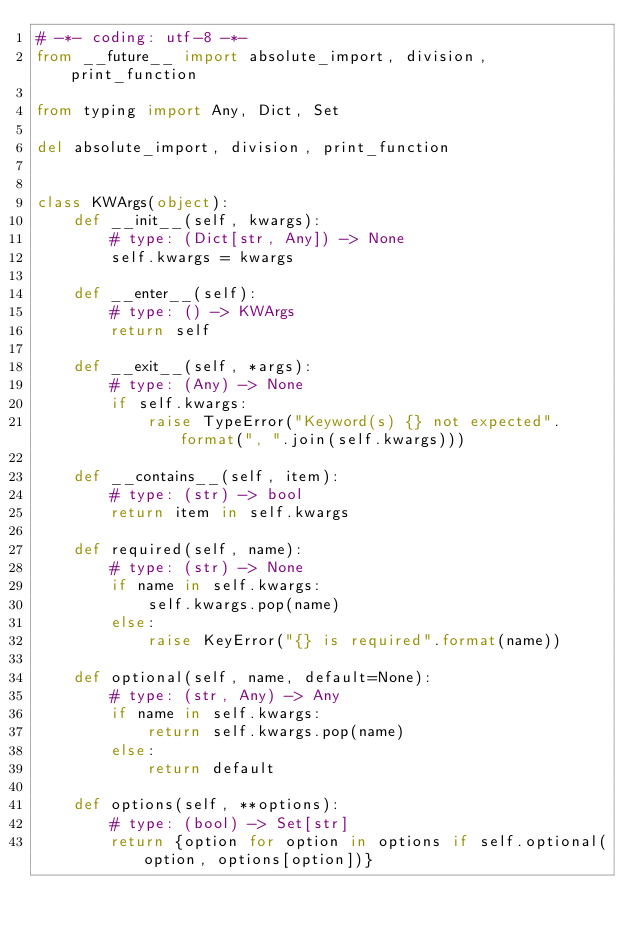<code> <loc_0><loc_0><loc_500><loc_500><_Python_># -*- coding: utf-8 -*-
from __future__ import absolute_import, division, print_function

from typing import Any, Dict, Set

del absolute_import, division, print_function


class KWArgs(object):
    def __init__(self, kwargs):
        # type: (Dict[str, Any]) -> None
        self.kwargs = kwargs

    def __enter__(self):
        # type: () -> KWArgs
        return self

    def __exit__(self, *args):
        # type: (Any) -> None
        if self.kwargs:
            raise TypeError("Keyword(s) {} not expected".format(", ".join(self.kwargs)))

    def __contains__(self, item):
        # type: (str) -> bool
        return item in self.kwargs

    def required(self, name):
        # type: (str) -> None
        if name in self.kwargs:
            self.kwargs.pop(name)
        else:
            raise KeyError("{} is required".format(name))

    def optional(self, name, default=None):
        # type: (str, Any) -> Any
        if name in self.kwargs:
            return self.kwargs.pop(name)
        else:
            return default

    def options(self, **options):
        # type: (bool) -> Set[str]
        return {option for option in options if self.optional(option, options[option])}
</code> 